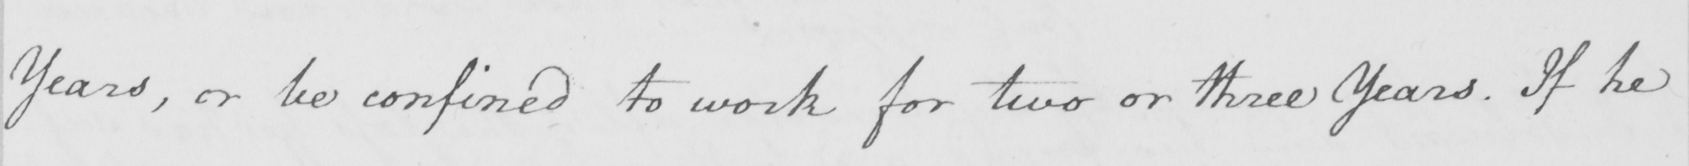Please transcribe the handwritten text in this image. Years , or be confined to work for two or three Years . If he 